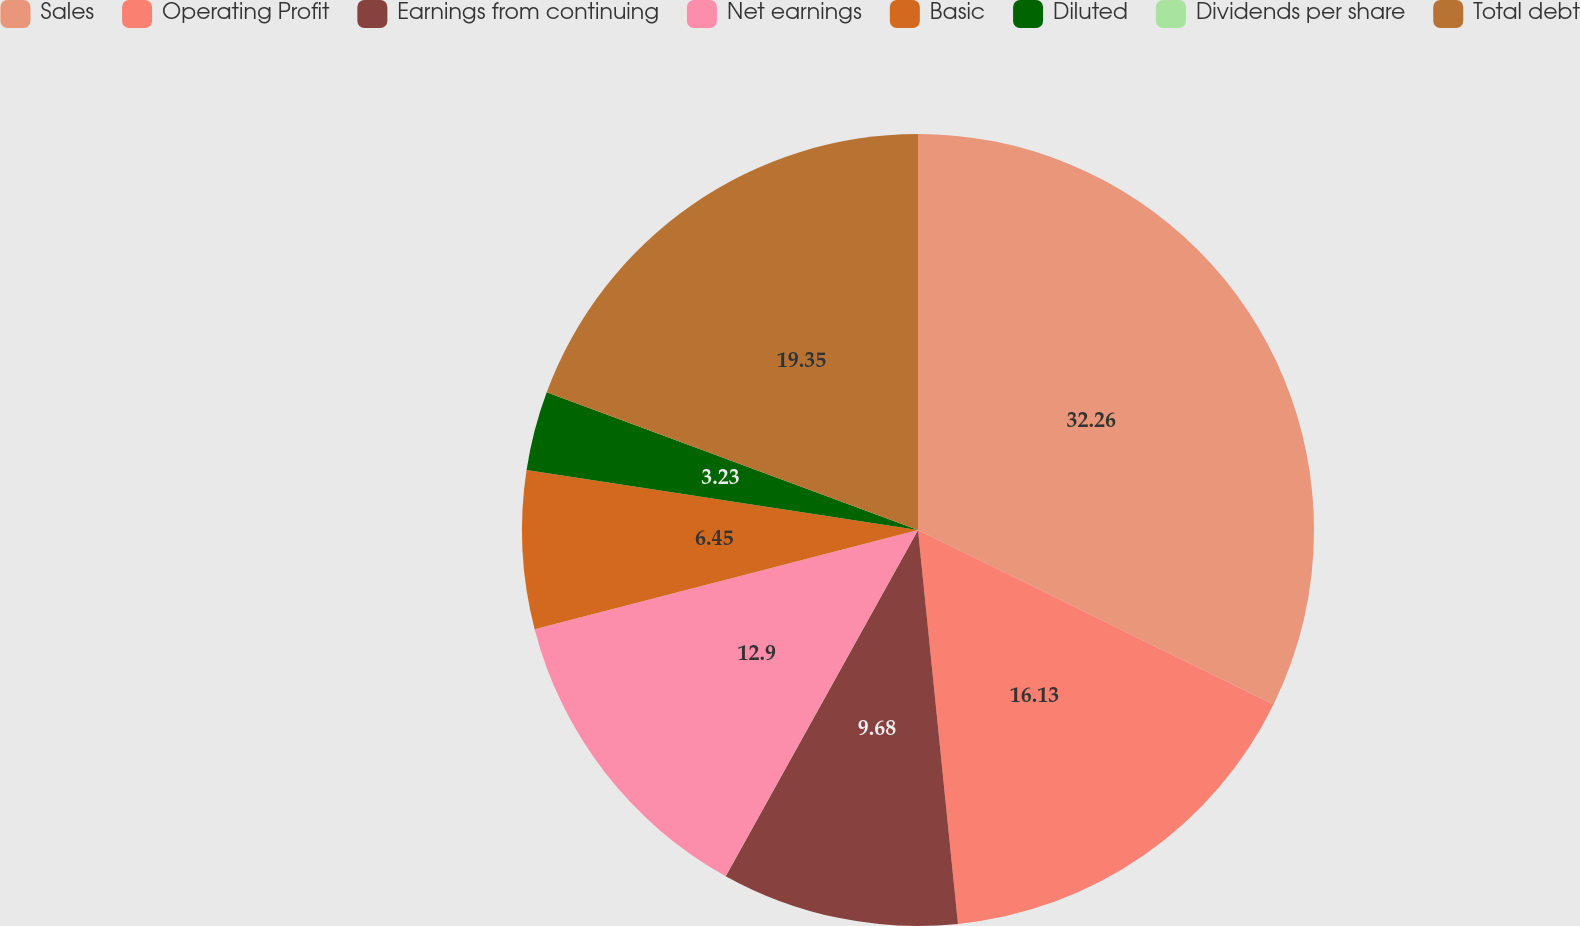<chart> <loc_0><loc_0><loc_500><loc_500><pie_chart><fcel>Sales<fcel>Operating Profit<fcel>Earnings from continuing<fcel>Net earnings<fcel>Basic<fcel>Diluted<fcel>Dividends per share<fcel>Total debt<nl><fcel>32.26%<fcel>16.13%<fcel>9.68%<fcel>12.9%<fcel>6.45%<fcel>3.23%<fcel>0.0%<fcel>19.35%<nl></chart> 